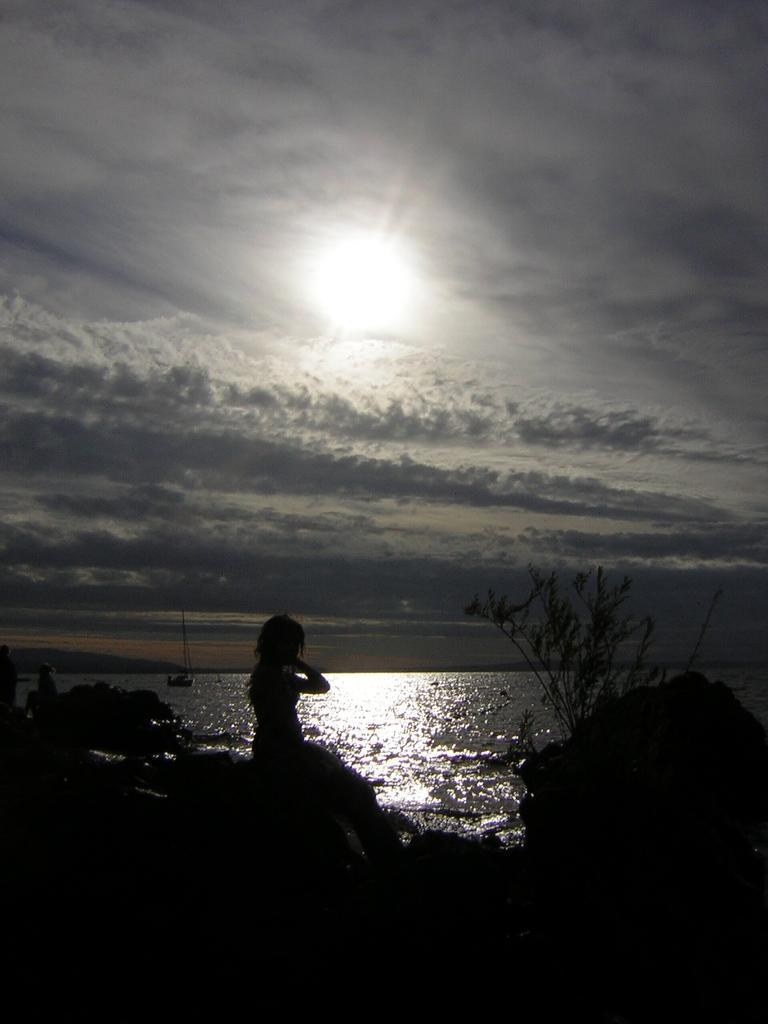Please provide a concise description of this image. In the picture we can see water near to it, we can see some rock a person sitting on it and some plant beside the person and in the background, we can see a boat in the water and behind it we can see a sky with clouds and sun. 